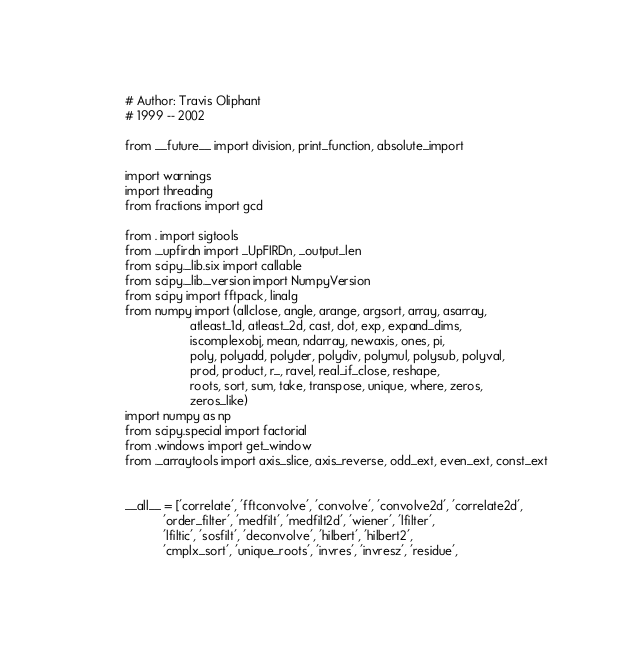Convert code to text. <code><loc_0><loc_0><loc_500><loc_500><_Python_># Author: Travis Oliphant
# 1999 -- 2002

from __future__ import division, print_function, absolute_import

import warnings
import threading
from fractions import gcd

from . import sigtools
from ._upfirdn import _UpFIRDn, _output_len
from scipy._lib.six import callable
from scipy._lib._version import NumpyVersion
from scipy import fftpack, linalg
from numpy import (allclose, angle, arange, argsort, array, asarray,
                   atleast_1d, atleast_2d, cast, dot, exp, expand_dims,
                   iscomplexobj, mean, ndarray, newaxis, ones, pi,
                   poly, polyadd, polyder, polydiv, polymul, polysub, polyval,
                   prod, product, r_, ravel, real_if_close, reshape,
                   roots, sort, sum, take, transpose, unique, where, zeros,
                   zeros_like)
import numpy as np
from scipy.special import factorial
from .windows import get_window
from ._arraytools import axis_slice, axis_reverse, odd_ext, even_ext, const_ext


__all__ = ['correlate', 'fftconvolve', 'convolve', 'convolve2d', 'correlate2d',
           'order_filter', 'medfilt', 'medfilt2d', 'wiener', 'lfilter',
           'lfiltic', 'sosfilt', 'deconvolve', 'hilbert', 'hilbert2',
           'cmplx_sort', 'unique_roots', 'invres', 'invresz', 'residue',</code> 